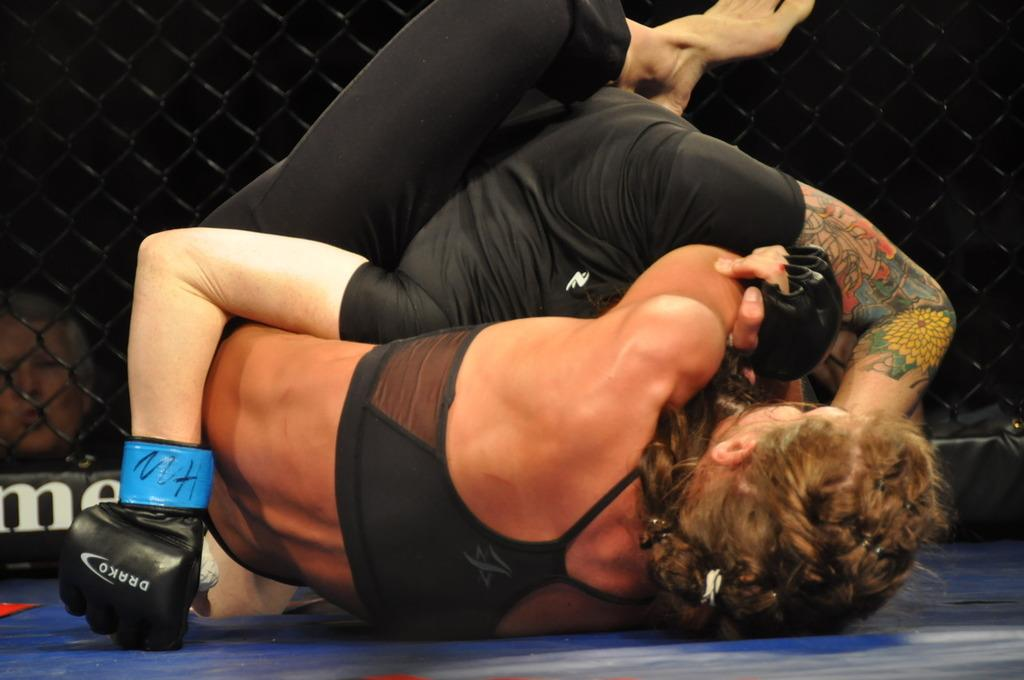Provide a one-sentence caption for the provided image. Two people are wrestling while wearing Drako gloves. 